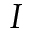Convert formula to latex. <formula><loc_0><loc_0><loc_500><loc_500>I</formula> 